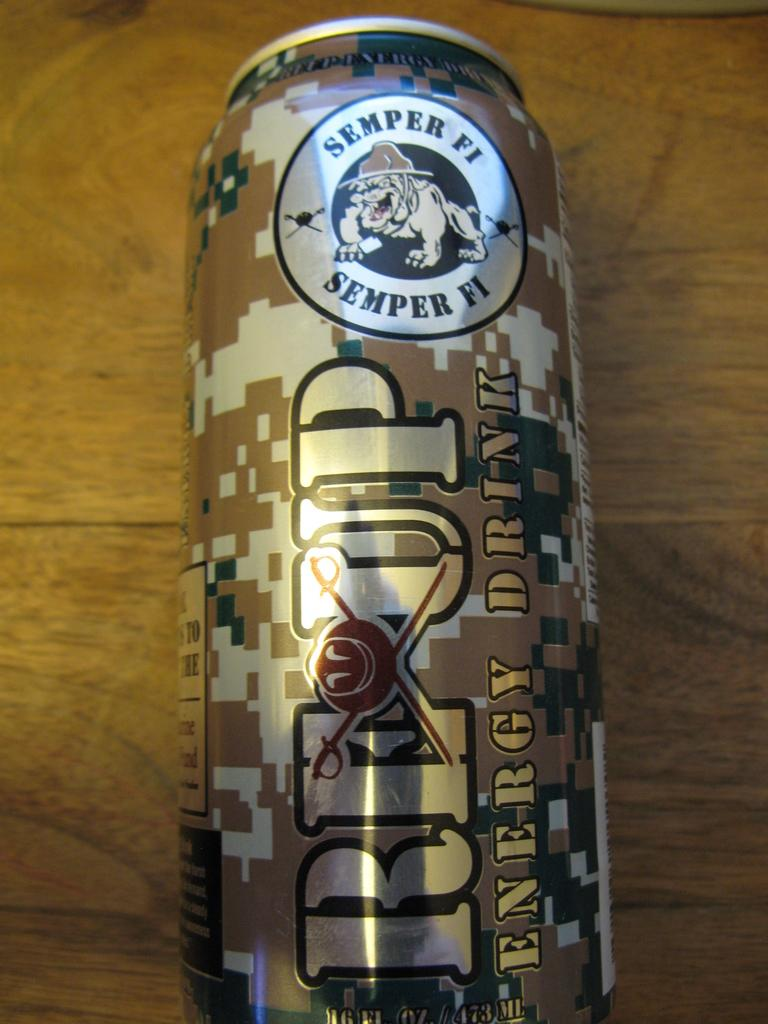<image>
Offer a succinct explanation of the picture presented. a semper fi can that is on a brown surface 